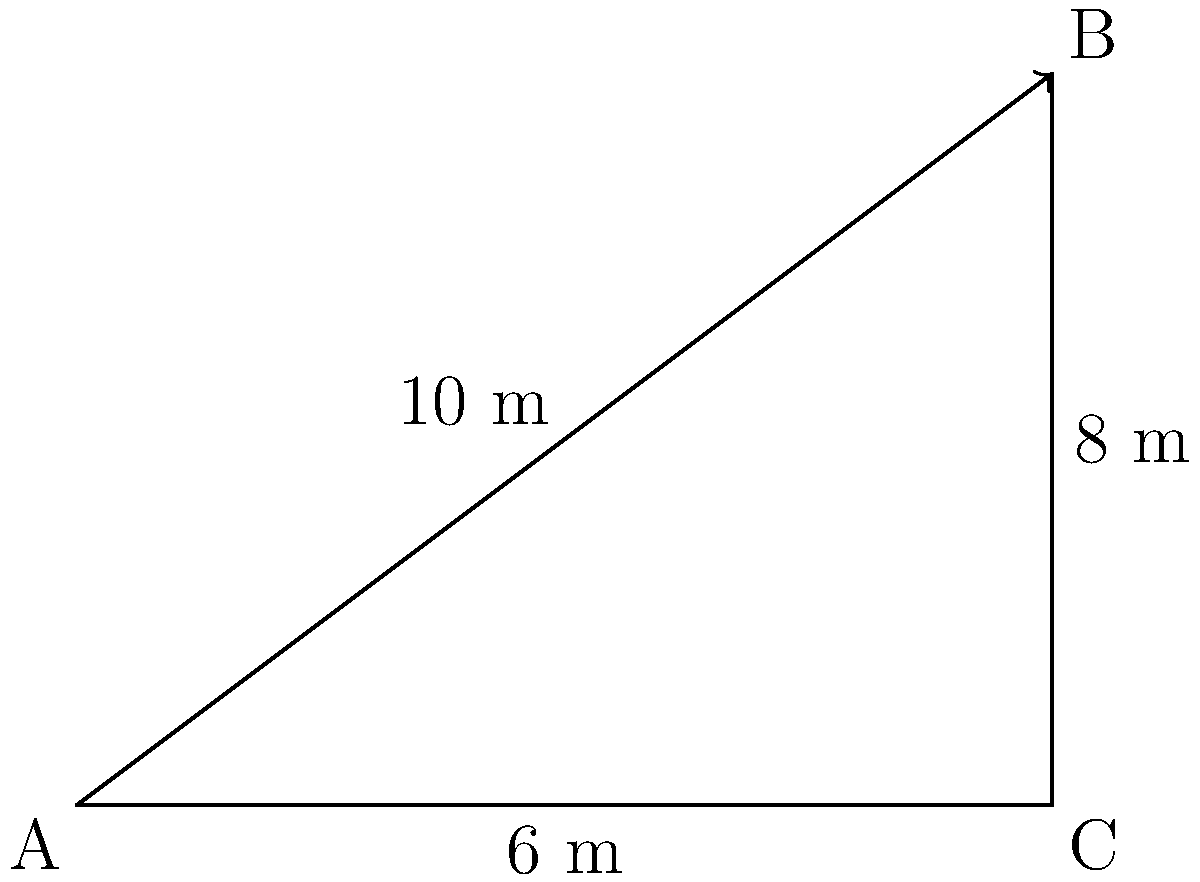As a safety equipment manufacturer, you're designing a new climbing rope system. A climber needs to ascend a vertical cliff face that's 6 meters high. The anchor point is 8 meters away from the base of the cliff. What is the optimal angle (in degrees) between the climbing rope and the horizontal ground to ensure maximum safety and efficiency for the climber? To find the optimal angle, we need to use trigonometry. Let's approach this step-by-step:

1) First, we can see that we have a right-angled triangle. The base of the triangle (horizontal distance) is 8 meters, and the height (vertical distance) is 6 meters.

2) We need to find the angle between the hypotenuse (the rope) and the horizontal ground. This angle is typically denoted as θ (theta).

3) We can use the tangent function to find this angle. The tangent of an angle in a right-angled triangle is the ratio of the opposite side to the adjacent side.

4) In this case:
   $tan(θ) = \frac{opposite}{adjacent} = \frac{6}{8} = \frac{3}{4} = 0.75$

5) To find the angle, we need to use the inverse tangent (arctan or tan^(-1)) function:
   $θ = tan^{-1}(0.75)$

6) Using a calculator or mathematical tables:
   $θ ≈ 36.87°$

7) For safety and efficiency, this angle provides a good balance between vertical lift and horizontal stability. It's not too steep (which would make it hard to climb) and not too shallow (which would put too much tension on the rope and anchor).
Answer: $36.87°$ 